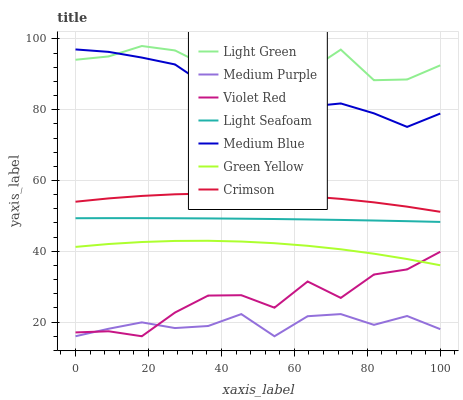Does Medium Purple have the minimum area under the curve?
Answer yes or no. Yes. Does Light Green have the maximum area under the curve?
Answer yes or no. Yes. Does Green Yellow have the minimum area under the curve?
Answer yes or no. No. Does Green Yellow have the maximum area under the curve?
Answer yes or no. No. Is Light Seafoam the smoothest?
Answer yes or no. Yes. Is Light Green the roughest?
Answer yes or no. Yes. Is Green Yellow the smoothest?
Answer yes or no. No. Is Green Yellow the roughest?
Answer yes or no. No. Does Violet Red have the lowest value?
Answer yes or no. Yes. Does Green Yellow have the lowest value?
Answer yes or no. No. Does Light Green have the highest value?
Answer yes or no. Yes. Does Green Yellow have the highest value?
Answer yes or no. No. Is Violet Red less than Light Green?
Answer yes or no. Yes. Is Medium Blue greater than Crimson?
Answer yes or no. Yes. Does Light Green intersect Medium Blue?
Answer yes or no. Yes. Is Light Green less than Medium Blue?
Answer yes or no. No. Is Light Green greater than Medium Blue?
Answer yes or no. No. Does Violet Red intersect Light Green?
Answer yes or no. No. 